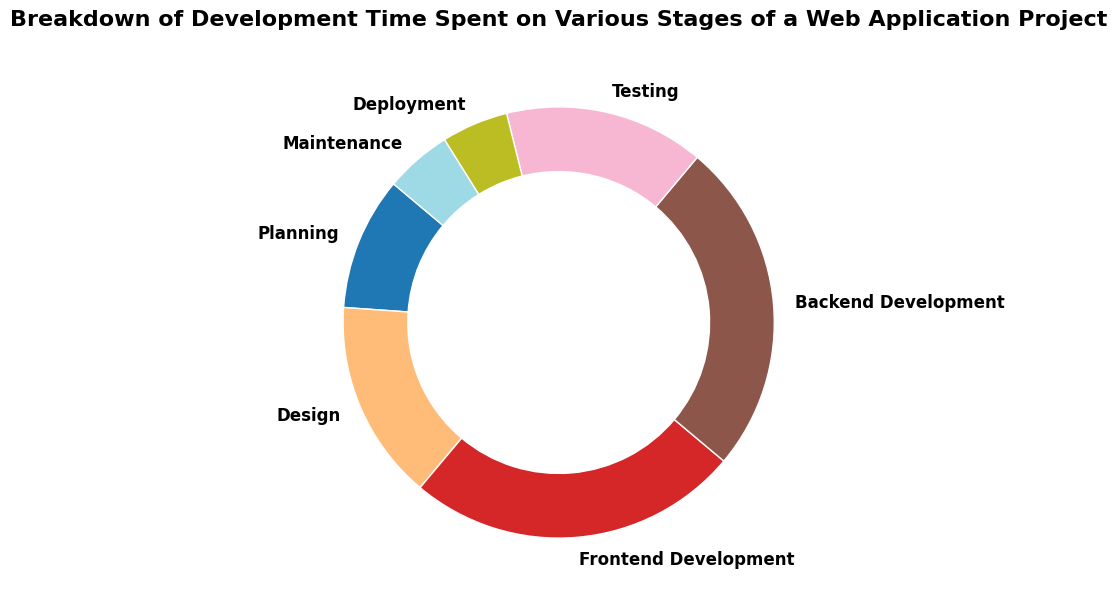What is the biggest category in terms of time spent? The largest segment on the pie chart, representing the highest percentage, is the biggest category. The "Frontend Development" and "Backend Development" categories are the largest, each at 25%.
Answer: Frontend Development and Backend Development What is the smallest category in terms of time spent? The smallest category will be represented by the smallest segment of the pie chart. Both "Deployment" and "Maintenance" have the smallest percentages, each at 5%.
Answer: Deployment and Maintenance What is the total percentage of time spent on Planning and Testing? To get the total percentage of time spent on Planning and Testing, add the percentages of these two categories: Planning (10%) + Testing (15%) = 25%.
Answer: 25% How much more time is spent on Frontend Development compared to Deployment? Subtract the percentage of time spent on Deployment from the percentage of time spent on Frontend Development. Frontend Development (25%) - Deployment (5%) = 20%.
Answer: 20% Which color represents the Design category? The color representing the Design category can be identified by looking at the segment labeled "Design" on the pie chart.
Answer: (Assuming the color from visual inspection) Green How much time is spent on both Frontend Development and Backend Development combined? Add the percentages of Frontend Development and Backend Development: Frontend Development (25%) + Backend Development (25%) = 50%.
Answer: 50% Is less time spent on Deployment than on Maintenance? Compare the percentages spent on Deployment and Maintenance. Both Deployment and Maintenance have the same percentage, which is 5%.
Answer: No Which categories combined make up more than half the total time? To find categories that combined make up more than half, add the percentages until the sum exceeds 50%. Frontend Development (25%) + Backend Development (25%) = 50%. Adding any other category (like Planning 10%) results in more than 50%.
Answer: Frontend Development, Backend Development, and Planning What percentage of time is not spent on Development (Frontend and Backend combined)? First, calculate the combined percentage for Frontend and Backend Development: (25% + 25% = 50%). Then subtract this from 100%: 100% - 50% = 50%.
Answer: 50% Which stage spends equal time on Design and Testing? Check the chart to see which categories have the same percentage values. Both Design and Testing are 15%.
Answer: Design and Testing 